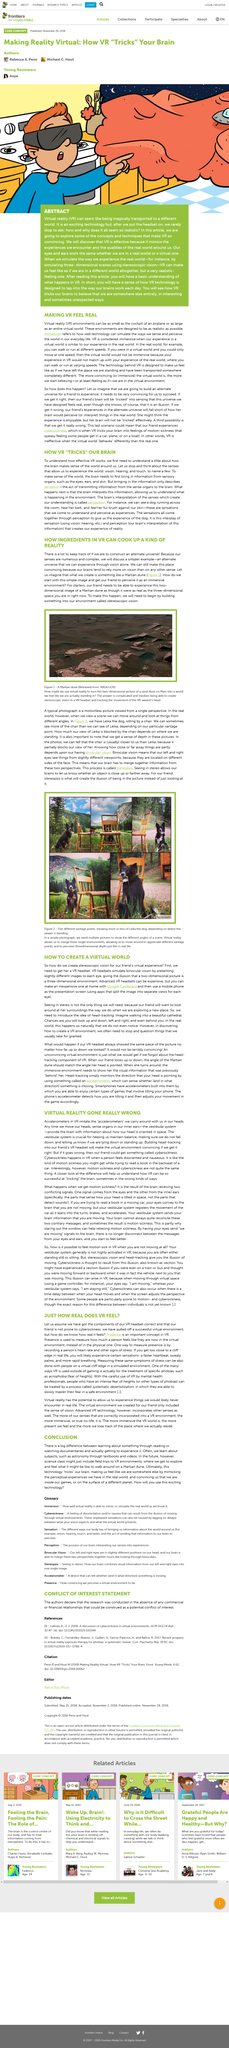Specify some key components in this picture. The process of converting a two-dimensional picture into a virtual reality world involves the creation of stereoscopic vision in a VR headset and the tracking of the movement of the VR wearer's head to create an immersive experience. This technology utilizes a sophisticated trickery of the brain, through the mimicking of real-world perceptions, to convincingly transport users into the virtual world of games or onto extraterrestrial planets, effectively deceiving the mind and creating a false sense of reality. It is essential to keep track of various details when creating an alternate universe because our senses are numerous and complex. The V in VR stands for virtual, which refers to the simulated or computer-generated environment that is designed to replicate a real-world environment or experience. In the future, science classes may include virtual reality field trips where students can explore and experience what it might be like to walk on a Martian dune. 